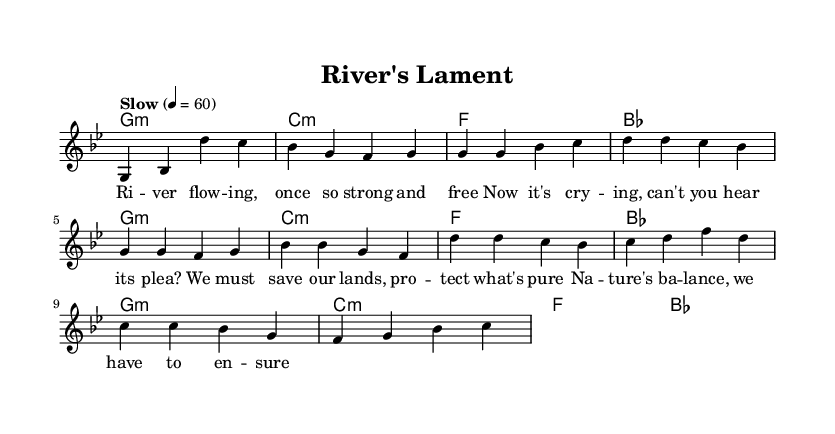What is the key signature of this music? The key signature is G minor, which has two flats (B flat and E flat). This is evident from the key indicated at the beginning of the score.
Answer: G minor What is the time signature of this piece? The time signature is 4/4, meaning there are four beats in each measure. This can be seen in the time signature notation at the beginning of the score.
Answer: 4/4 What is the tempo of the song? The tempo is marked as "Slow" with a metronome marking of 60 beats per minute. This is indicated in the tempo marking found at the top of the score.
Answer: Slow How many measures are in the verse? The verse consists of eight measures. By counting the vertical lines that separate each measure in the melody section, we find that there are eight distinct measures labeled as the verse.
Answer: 8 What is the main theme of the lyrics? The main theme of the lyrics addresses the cry of nature and the need for conservation. This message is conveyed through the words "Now it's crying, can't you hear its plea?" indicating the urgent call to protect the environment.
Answer: Conservation Which part of the music structure does the chorus represent? The chorus serves as a repeated, climactic section that emphasizes the message of protecting nature and is situated after the verse. It typically contrasts with the verse, reinforcing the main themes in a more memorable way.
Answer: Chorus 